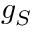<formula> <loc_0><loc_0><loc_500><loc_500>g _ { S }</formula> 